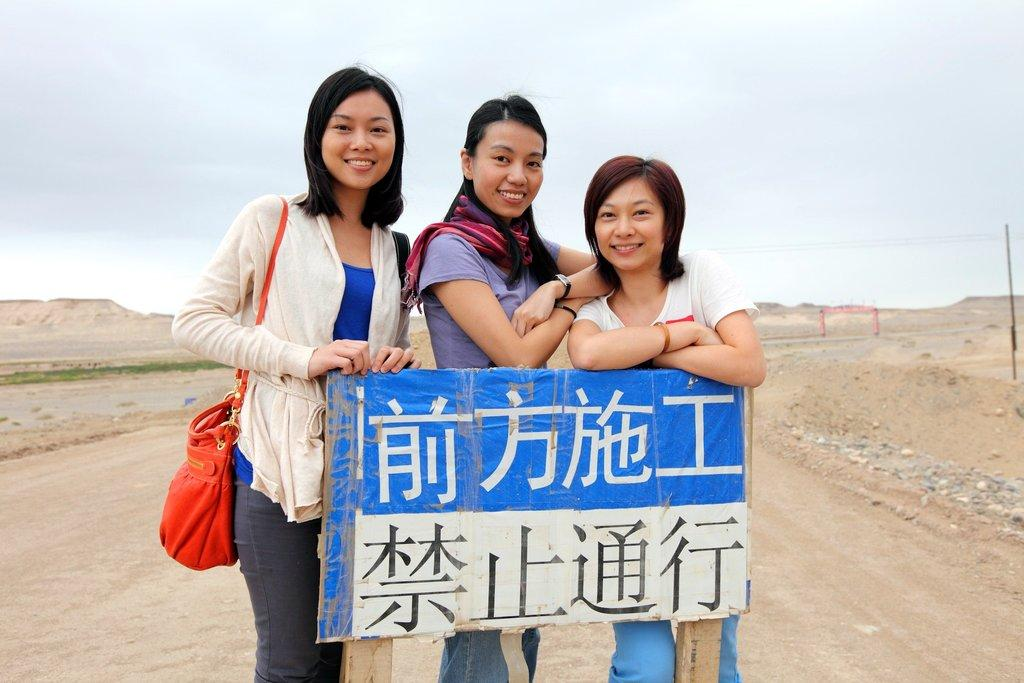What can be seen in the image involving people? There are people standing in the image. What is the board with written text used for in the image? The board with written text is likely used for communication or information purposes. What type of infrastructure is visible in the image? Cable wires are visible in the image. What natural elements are present in the image? Stones and hills are present in the image. What is visible at the top of the image? The sky is visible at the top of the image. How many crows are sitting on the stones in the image? There are no crows present in the image; only people, written text, cable wires, stones, hills, and the sky are visible. What type of minister is depicted in the image? There is no minister depicted in the image. 